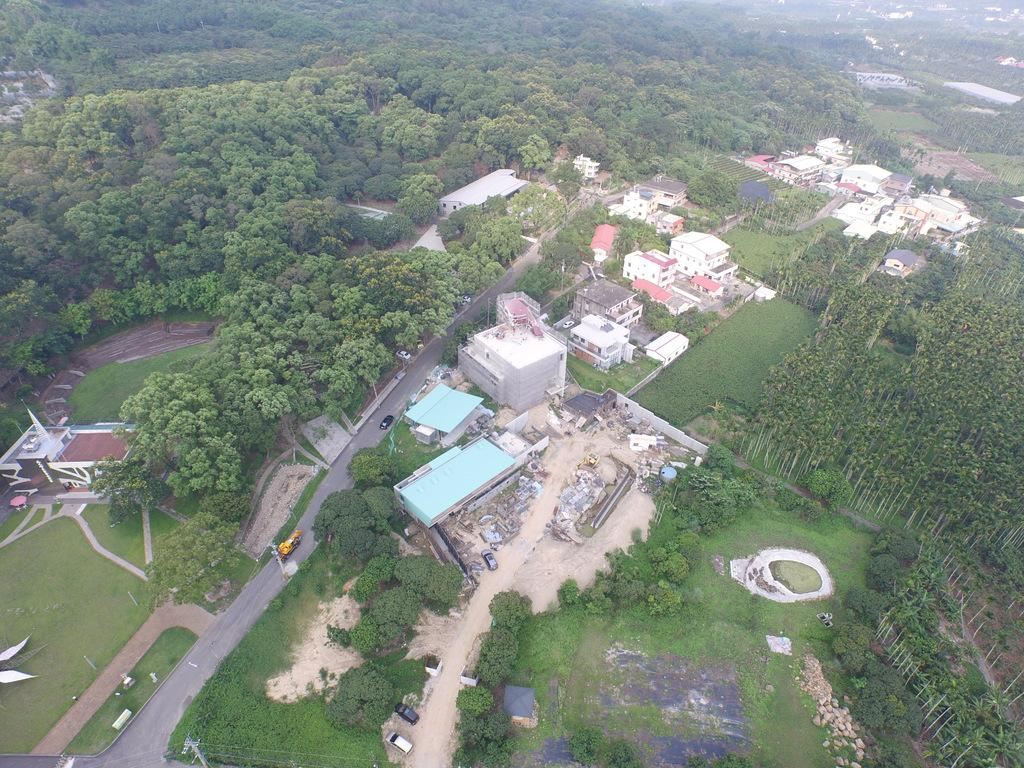What type of view is depicted in the image? The image is an aerial view. What type of vegetation can be seen in the image? There are trees in the image. What type of structures can be seen in the image? There are buildings, sheds, and towers in the image. What type of infrastructure can be seen in the image? There are roads in the image. What type of transportation can be seen in the image? There are motor vehicles in the image. What type of natural element can be seen in the image? There are stones in the image. What type of surface is visible in the image? There is ground visible in the image. What type of juice is being served in the image? There is no juice present in the image; it is an aerial view of a landscape with trees, buildings, sheds, towers, roads, motor vehicles, stones, and ground. 